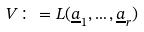<formula> <loc_0><loc_0><loc_500><loc_500>V \colon = L ( \underline { a } _ { 1 } , \dots , \underline { a } _ { r } )</formula> 